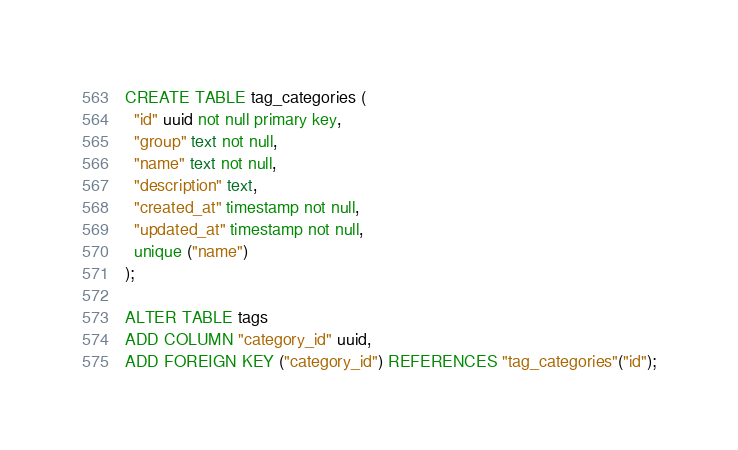Convert code to text. <code><loc_0><loc_0><loc_500><loc_500><_SQL_>CREATE TABLE tag_categories (
  "id" uuid not null primary key,
  "group" text not null,
  "name" text not null,
  "description" text,
  "created_at" timestamp not null,
  "updated_at" timestamp not null,
  unique ("name")
);

ALTER TABLE tags
ADD COLUMN "category_id" uuid,
ADD FOREIGN KEY ("category_id") REFERENCES "tag_categories"("id");
</code> 